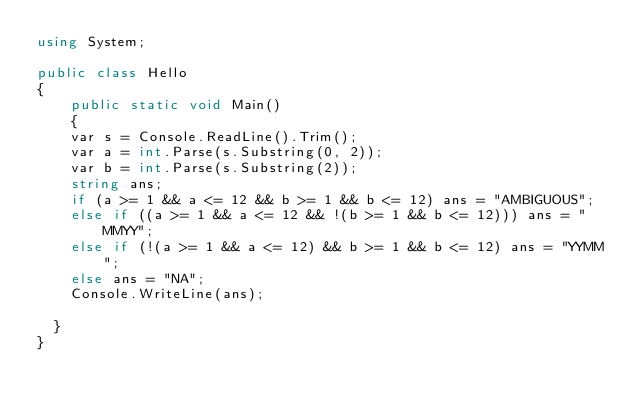<code> <loc_0><loc_0><loc_500><loc_500><_C#_>using System;

public class Hello
{
    public static void Main()
    {
		var s = Console.ReadLine().Trim();
		var a = int.Parse(s.Substring(0, 2));
		var b = int.Parse(s.Substring(2));
		string ans;
		if (a >= 1 && a <= 12 && b >= 1 && b <= 12) ans = "AMBIGUOUS";
		else if ((a >= 1 && a <= 12 && !(b >= 1 && b <= 12))) ans = "MMYY";
		else if (!(a >= 1 && a <= 12) && b >= 1 && b <= 12) ans = "YYMM";
		else ans = "NA";
		Console.WriteLine(ans);

	}
}</code> 